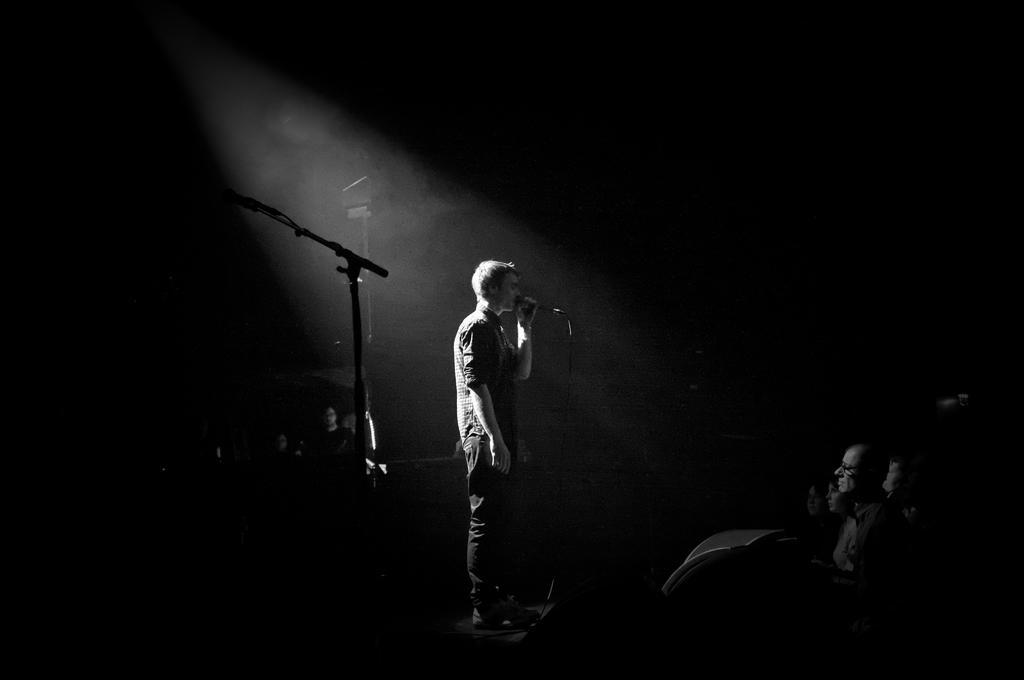Describe this image in one or two sentences. This image is taken in the dark where we can see a person standing and holding the mic in his hands. Here we can see these people are sitting here and we can see the mic stand here. In the background, we can see a few more people here. 